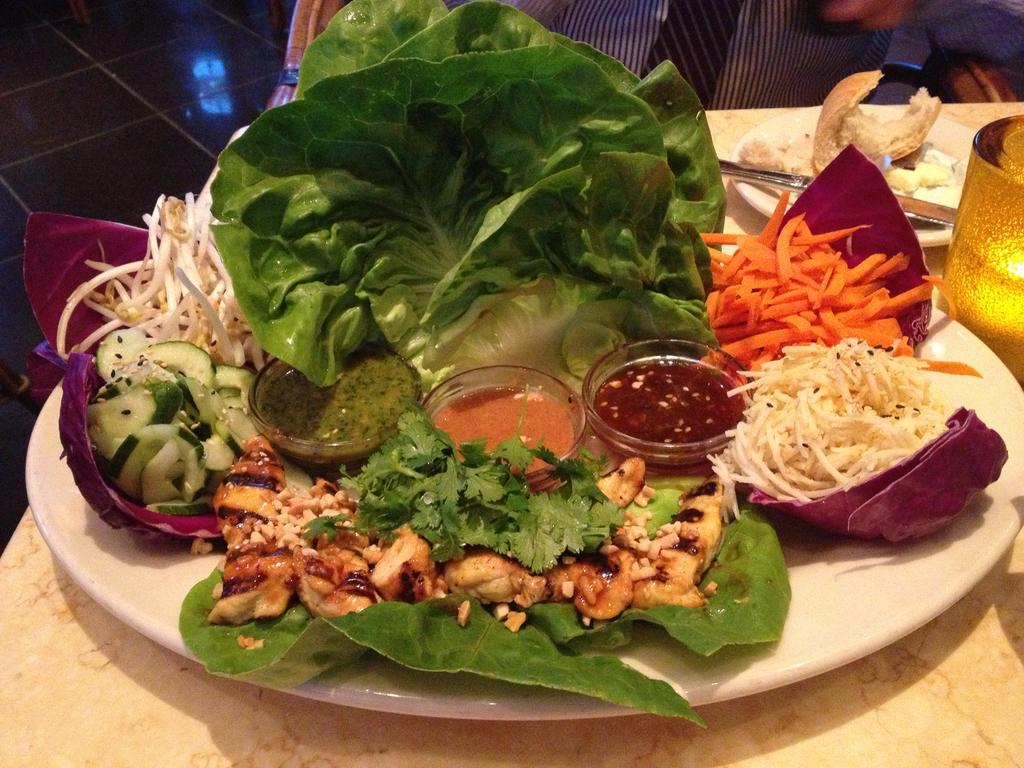What is the main piece of furniture in the image? There is a table in the image. What items can be seen on the table? There are plates, a knife, a lamp, sauces, bowls, and leaves on the table. What type of food is visible on the table? There is food on the table. Can you describe the person in the background of the image? There is a person in the background of the image, but no specific details are provided. What type of ants can be seen crawling on the food in the image? There are no ants present in the image; it only shows food on the table. What channel is the person in the background of the image watching? There is no information about a television or channel in the image, and the person in the background is not described in detail. 